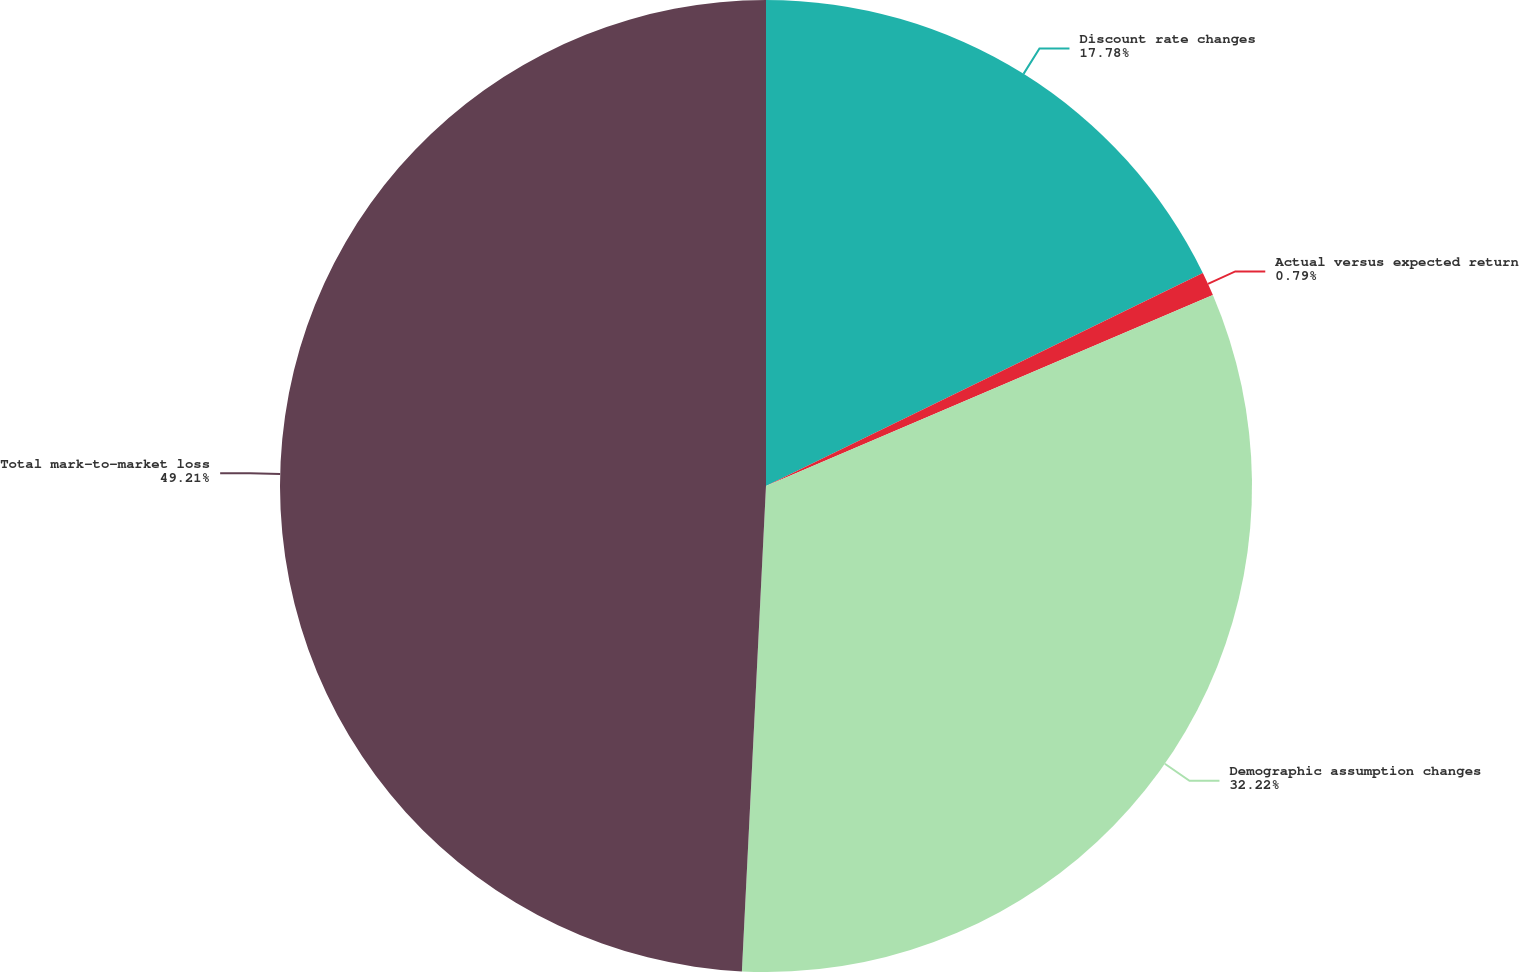Convert chart to OTSL. <chart><loc_0><loc_0><loc_500><loc_500><pie_chart><fcel>Discount rate changes<fcel>Actual versus expected return<fcel>Demographic assumption changes<fcel>Total mark-to-market loss<nl><fcel>17.78%<fcel>0.79%<fcel>32.22%<fcel>49.21%<nl></chart> 